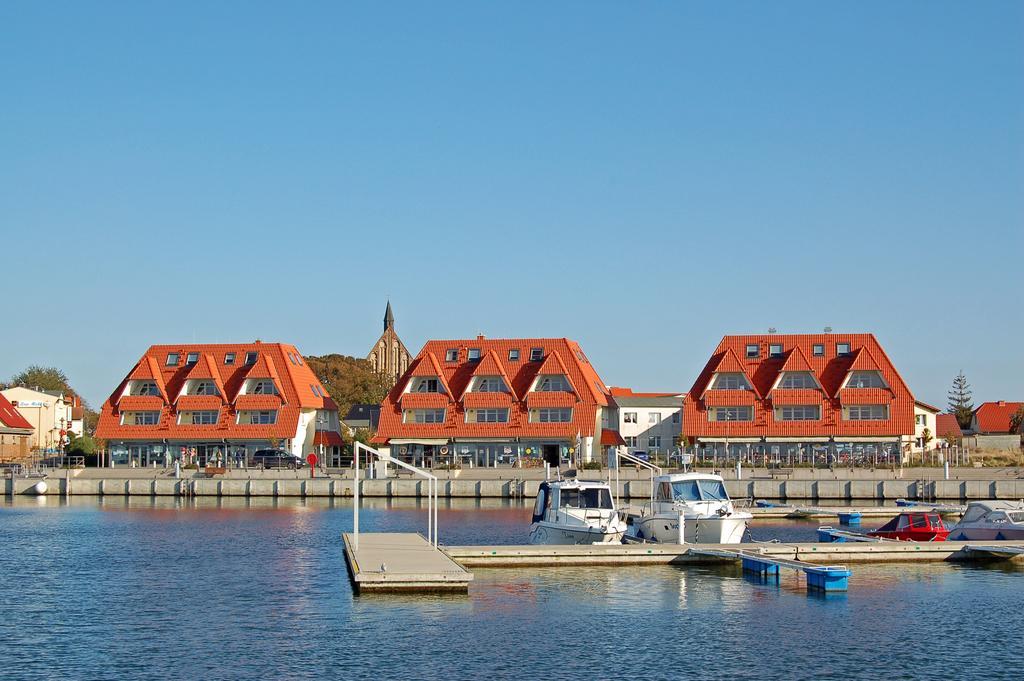Please provide a concise description of this image. In this image there are boats sailing on the water. Right side there is a bridge. Middle of the image there is a wall. Behind there are vehicles. Background there are buildings and trees. Top of the image there is sky. 